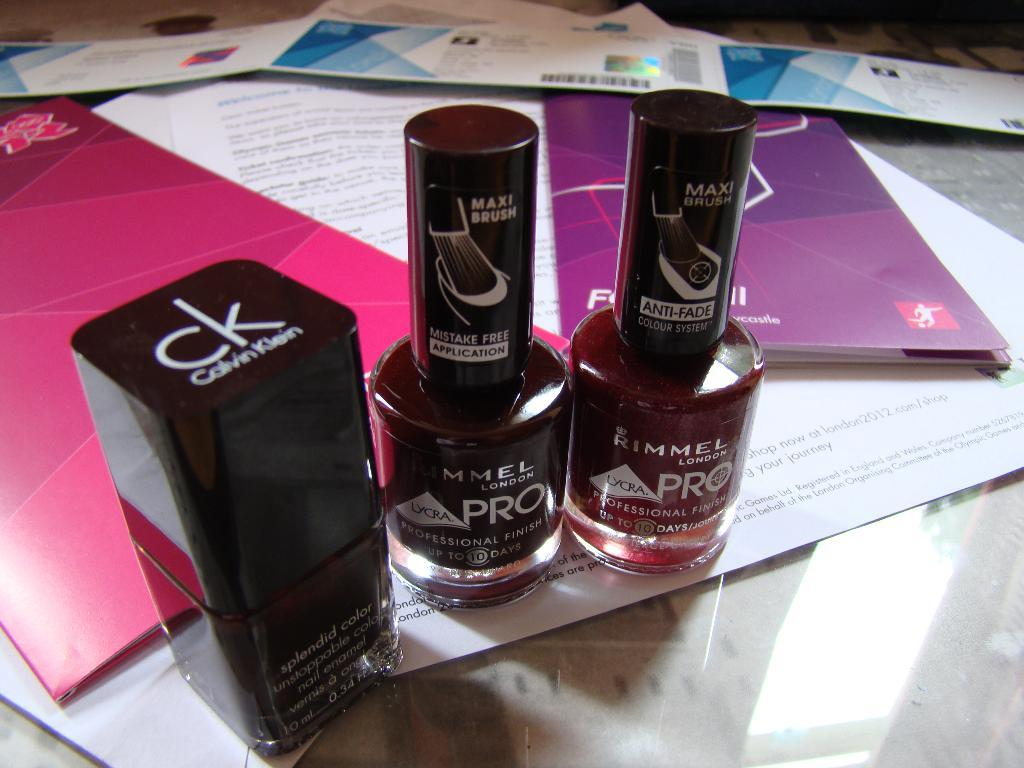<image>
Render a clear and concise summary of the photo. a couple of bottles with the word pro on both of them 